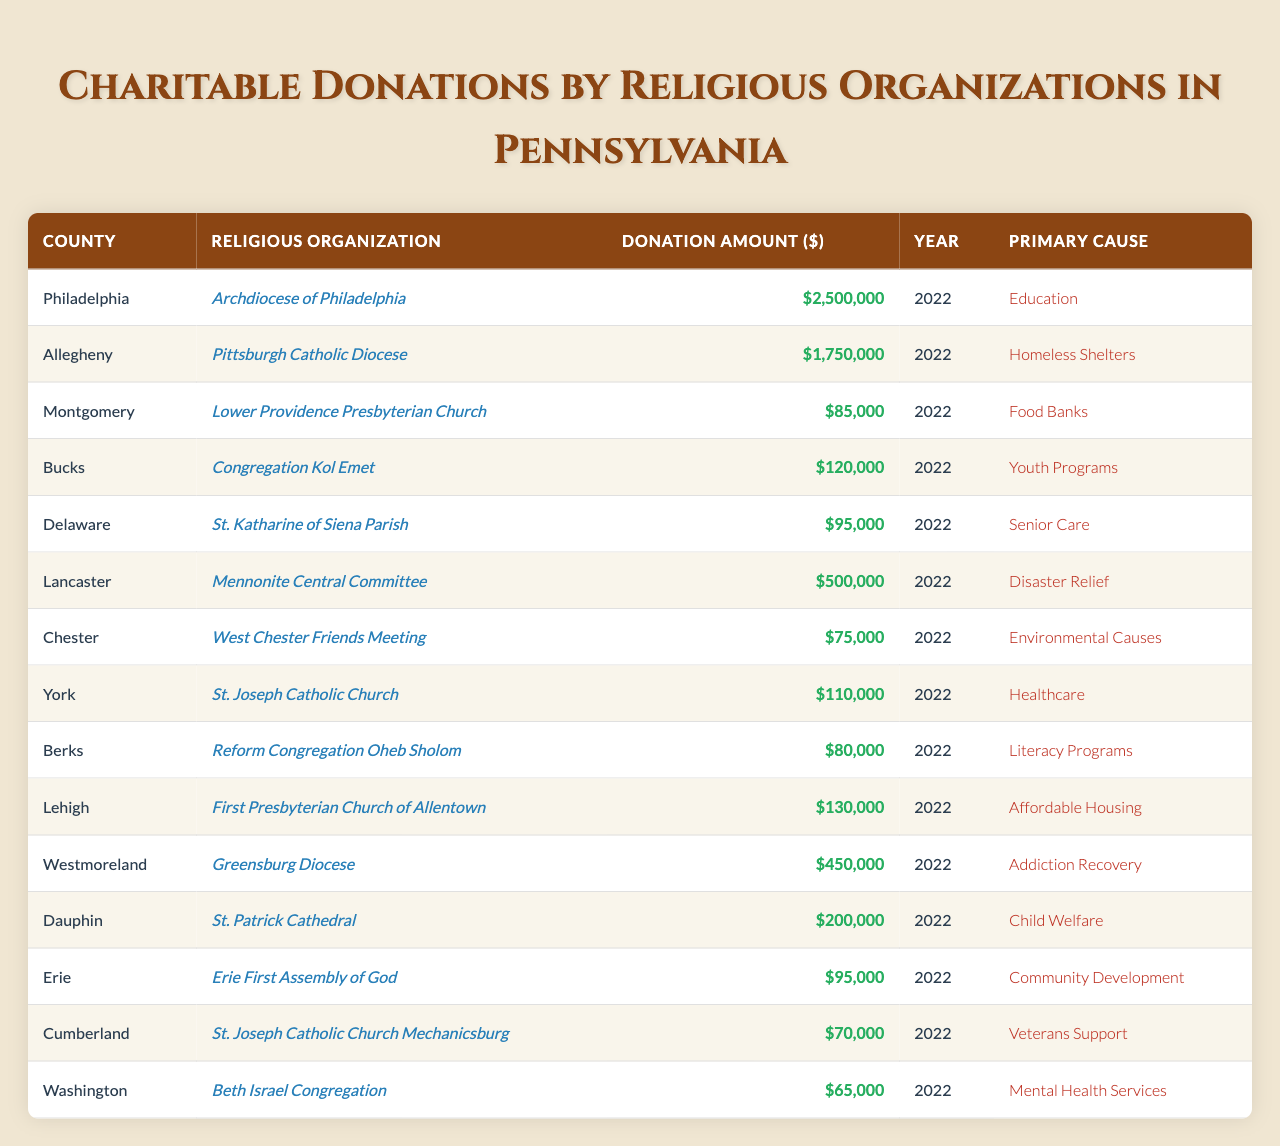What was the highest donation amount recorded in 2022? Looking at the table, the highest donation amount listed is 2,500,000 dollars from the Archdiocese of Philadelphia in Philadelphia county in 2022.
Answer: 2,500,000 Which county had the lowest charitable donation in 2022? The table shows that Washington county had the lowest donation amount of 65,000 dollars from Beth Israel Congregation in 2022.
Answer: 65,000 How much total money was donated to food banks in 2022? The only donation specified for food banks was from Lower Providence Presbyterian Church in Montgomery county, which donated 85,000 dollars. Thus, the total amount for food banks is 85,000 dollars.
Answer: 85,000 Did any religious organization donate more than 1 million dollars in 2022? The table indicates that the Archdiocese of Philadelphia donated 2,500,000 dollars, which is indeed more than 1 million dollars.
Answer: Yes What is the average donation amount from the organizations in the table? First, add the total donation amounts: 2,500,000 + 1,750,000 + 85,000 + 120,000 + 95,000 + 500,000 + 75,000 + 110,000 + 80,000 + 130,000 + 450,000 + 200,000 + 95,000 + 70,000 + 65,000 = 6,855,000. There are 15 organizations, so the average is 6,855,000 / 15 = 457,000.
Answer: 457,000 Which primary cause received the highest total donations? Tallying the donations for each primary cause: Education (2,500,000), Homeless Shelters (1,750,000), Food Banks (85,000), Youth Programs (120,000), Senior Care (95,000), Disaster Relief (500,000), Environmental Causes (75,000), Healthcare (110,000), Literacy Programs (80,000), Affordable Housing (130,000), Addiction Recovery (450,000), Child Welfare (200,000), Community Development (95,000), Veterans Support (70,000), and Mental Health Services (65,000). Education is the highest cause at 2,500,000 dollars.
Answer: Education What percentage of the total donations came from the Mennonite Central Committee in Lancaster? The total donations amount to 6,855,000 dollars, and Mennonite Central Committee donated 500,000 dollars. To find the percentage: (500,000 / 6,855,000) * 100 = approximately 7.29%.
Answer: 7.29% Which religious organization focuses on addiction recovery and how much did they donate? The table shows that the Greensburg Diocese in Westmoreland county focuses on addiction recovery and donated 450,000 dollars in 2022.
Answer: Greensburg Diocese, 450,000 